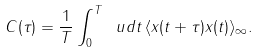<formula> <loc_0><loc_0><loc_500><loc_500>C ( \tau ) = \frac { 1 } { T } \int _ { 0 } ^ { T } \ u d t \, \langle x ( t + \tau ) x ( t ) \rangle _ { \infty } .</formula> 